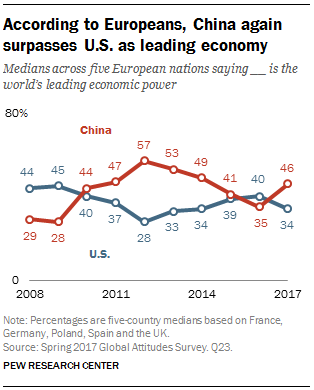Give some essential details in this illustration. The average of the last three years of data in China is 40.66. The blue line represents the country of the United States. 